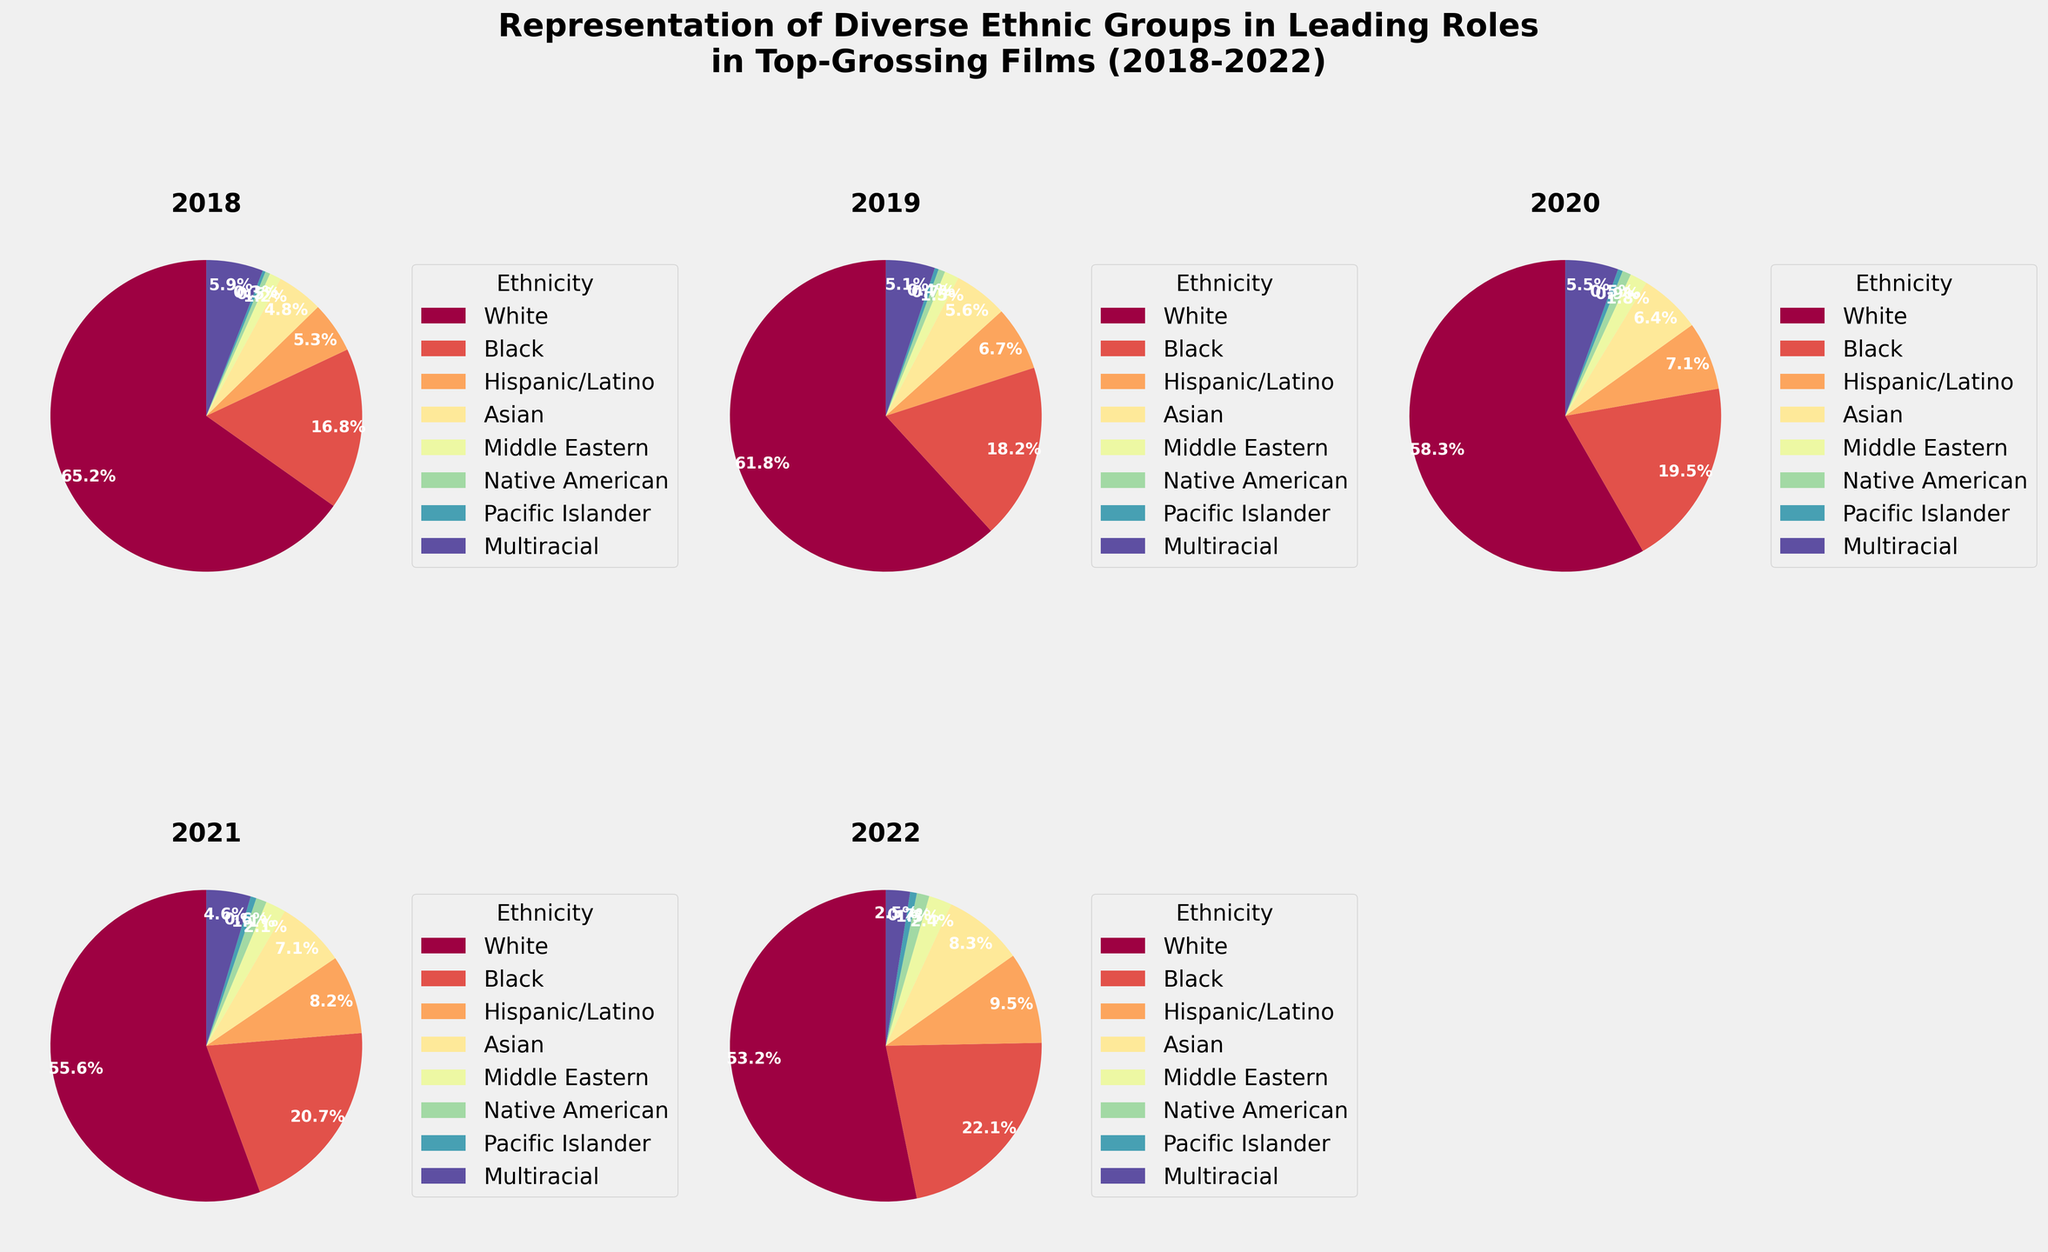Which ethnic group saw the highest increase in representation from 2018 to 2022? First, note the 2022 and 2018 values for each ethnic group. The increase for each group can be calculated by subtracting the 2018 percentage from the 2022 percentage. The group with the highest result is the one with the highest increase.
Answer: Black (5.3%) Which ethnic group had the lowest representation each year from 2018 to 2022? By checking the percentage for each group yearly, you'll find that Pacific Islander consistently holds the lowest proportion.
Answer: Pacific Islander What's the average representation of Asian actors from 2018 to 2022? Add the percentages for Asian actors from 2018 to 2022 and divide by the number of years (5). (4.8 + 5.6 + 6.4 + 7.1 + 8.3)/5 = 6.44%
Answer: 6.4% Did the representation of multiracial actors increase or decrease from 2018 to 2022? By how much? Compare the multiracial representation values for 2018 (5.9) and 2022 (2.5). Subtract the 2022 value from the 2018 value to find the change: 5.9 - 2.5 = 3.4% decrease.
Answer: Decrease by 3.4% Which ethnic groups had a representation of under 5% in 2022? Check the pie chart values for 2022 and identify any groups with a percentage below 5%. The groups are Middle Eastern, Native American, Pacific Islander, and Multiracial.
Answer: Middle Eastern, Native American, Pacific Islander, Multiracial If you combine the percentages of Hispanic/Latino and Asian actors in 2021, does their combined representation exceed that of Black actors in 2021? Add the percentage values for Hispanic/Latino (8.2) and Asian (7.1) in 2021, then compare it to the Black representation (20.7). 8.2 + 7.1 = 15.3, which is less than 20.7.
Answer: No Which year saw the highest representation of Hispanic/Latino actors? By examining the charts, it is clear the representation increased each year, peaking in 2022 at 9.5%.
Answer: 2022 How did the representation of White actors change from 2018 to 2022? Calculate the difference in percentages using the values for White actors in 2018 (65.2) and in 2022 (53.2): 65.2 - 53.2 = 12.0% decrease.
Answer: Decrease by 12.0% In 2020, which ethnic group had the highest representation after White actors? Referring to the 2020 pie chart, the group with the highest percentage after White (58.3) is Black (19.5).
Answer: Black 